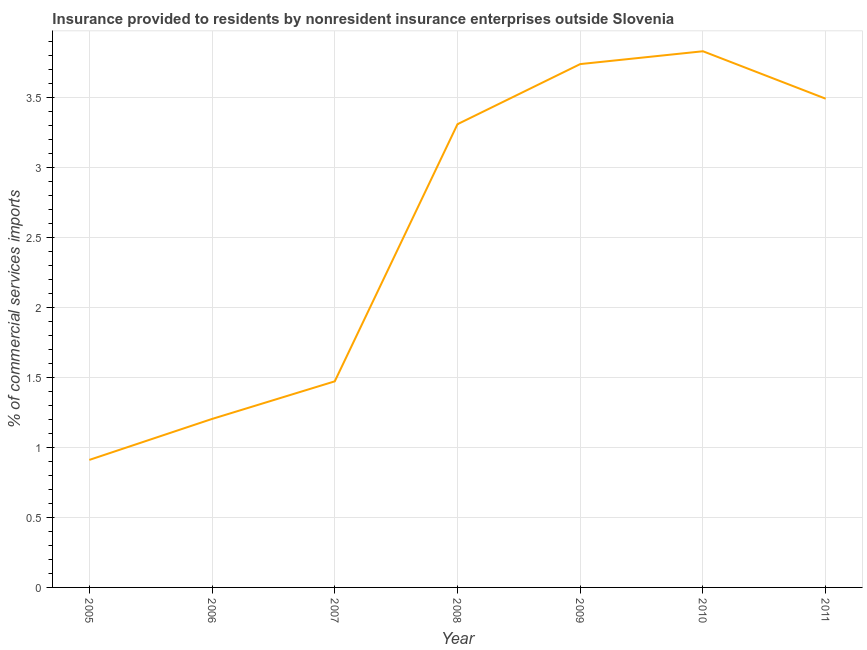What is the insurance provided by non-residents in 2008?
Make the answer very short. 3.31. Across all years, what is the maximum insurance provided by non-residents?
Make the answer very short. 3.83. Across all years, what is the minimum insurance provided by non-residents?
Your answer should be very brief. 0.91. In which year was the insurance provided by non-residents maximum?
Offer a terse response. 2010. In which year was the insurance provided by non-residents minimum?
Your answer should be compact. 2005. What is the sum of the insurance provided by non-residents?
Provide a short and direct response. 17.95. What is the difference between the insurance provided by non-residents in 2005 and 2010?
Provide a succinct answer. -2.92. What is the average insurance provided by non-residents per year?
Provide a succinct answer. 2.56. What is the median insurance provided by non-residents?
Ensure brevity in your answer.  3.31. What is the ratio of the insurance provided by non-residents in 2005 to that in 2007?
Your answer should be compact. 0.62. What is the difference between the highest and the second highest insurance provided by non-residents?
Provide a short and direct response. 0.09. What is the difference between the highest and the lowest insurance provided by non-residents?
Offer a terse response. 2.92. Does the insurance provided by non-residents monotonically increase over the years?
Provide a succinct answer. No. Are the values on the major ticks of Y-axis written in scientific E-notation?
Offer a very short reply. No. What is the title of the graph?
Your response must be concise. Insurance provided to residents by nonresident insurance enterprises outside Slovenia. What is the label or title of the X-axis?
Offer a very short reply. Year. What is the label or title of the Y-axis?
Your response must be concise. % of commercial services imports. What is the % of commercial services imports of 2005?
Offer a very short reply. 0.91. What is the % of commercial services imports of 2006?
Ensure brevity in your answer.  1.2. What is the % of commercial services imports of 2007?
Provide a short and direct response. 1.47. What is the % of commercial services imports in 2008?
Your response must be concise. 3.31. What is the % of commercial services imports of 2009?
Your response must be concise. 3.74. What is the % of commercial services imports of 2010?
Give a very brief answer. 3.83. What is the % of commercial services imports in 2011?
Offer a very short reply. 3.49. What is the difference between the % of commercial services imports in 2005 and 2006?
Offer a very short reply. -0.29. What is the difference between the % of commercial services imports in 2005 and 2007?
Keep it short and to the point. -0.56. What is the difference between the % of commercial services imports in 2005 and 2008?
Make the answer very short. -2.4. What is the difference between the % of commercial services imports in 2005 and 2009?
Provide a short and direct response. -2.83. What is the difference between the % of commercial services imports in 2005 and 2010?
Provide a short and direct response. -2.92. What is the difference between the % of commercial services imports in 2005 and 2011?
Your answer should be compact. -2.58. What is the difference between the % of commercial services imports in 2006 and 2007?
Your response must be concise. -0.27. What is the difference between the % of commercial services imports in 2006 and 2008?
Your answer should be very brief. -2.1. What is the difference between the % of commercial services imports in 2006 and 2009?
Keep it short and to the point. -2.53. What is the difference between the % of commercial services imports in 2006 and 2010?
Offer a very short reply. -2.63. What is the difference between the % of commercial services imports in 2006 and 2011?
Provide a short and direct response. -2.29. What is the difference between the % of commercial services imports in 2007 and 2008?
Provide a short and direct response. -1.84. What is the difference between the % of commercial services imports in 2007 and 2009?
Make the answer very short. -2.27. What is the difference between the % of commercial services imports in 2007 and 2010?
Provide a succinct answer. -2.36. What is the difference between the % of commercial services imports in 2007 and 2011?
Provide a short and direct response. -2.02. What is the difference between the % of commercial services imports in 2008 and 2009?
Your answer should be very brief. -0.43. What is the difference between the % of commercial services imports in 2008 and 2010?
Your answer should be very brief. -0.52. What is the difference between the % of commercial services imports in 2008 and 2011?
Make the answer very short. -0.18. What is the difference between the % of commercial services imports in 2009 and 2010?
Provide a succinct answer. -0.09. What is the difference between the % of commercial services imports in 2009 and 2011?
Your answer should be very brief. 0.25. What is the difference between the % of commercial services imports in 2010 and 2011?
Your answer should be very brief. 0.34. What is the ratio of the % of commercial services imports in 2005 to that in 2006?
Offer a very short reply. 0.76. What is the ratio of the % of commercial services imports in 2005 to that in 2007?
Give a very brief answer. 0.62. What is the ratio of the % of commercial services imports in 2005 to that in 2008?
Offer a terse response. 0.28. What is the ratio of the % of commercial services imports in 2005 to that in 2009?
Your answer should be compact. 0.24. What is the ratio of the % of commercial services imports in 2005 to that in 2010?
Keep it short and to the point. 0.24. What is the ratio of the % of commercial services imports in 2005 to that in 2011?
Provide a short and direct response. 0.26. What is the ratio of the % of commercial services imports in 2006 to that in 2007?
Keep it short and to the point. 0.82. What is the ratio of the % of commercial services imports in 2006 to that in 2008?
Keep it short and to the point. 0.36. What is the ratio of the % of commercial services imports in 2006 to that in 2009?
Offer a terse response. 0.32. What is the ratio of the % of commercial services imports in 2006 to that in 2010?
Your answer should be compact. 0.31. What is the ratio of the % of commercial services imports in 2006 to that in 2011?
Ensure brevity in your answer.  0.34. What is the ratio of the % of commercial services imports in 2007 to that in 2008?
Offer a terse response. 0.45. What is the ratio of the % of commercial services imports in 2007 to that in 2009?
Give a very brief answer. 0.39. What is the ratio of the % of commercial services imports in 2007 to that in 2010?
Your answer should be compact. 0.38. What is the ratio of the % of commercial services imports in 2007 to that in 2011?
Your answer should be compact. 0.42. What is the ratio of the % of commercial services imports in 2008 to that in 2009?
Provide a succinct answer. 0.89. What is the ratio of the % of commercial services imports in 2008 to that in 2010?
Your answer should be very brief. 0.86. What is the ratio of the % of commercial services imports in 2008 to that in 2011?
Keep it short and to the point. 0.95. What is the ratio of the % of commercial services imports in 2009 to that in 2011?
Your response must be concise. 1.07. What is the ratio of the % of commercial services imports in 2010 to that in 2011?
Provide a short and direct response. 1.1. 